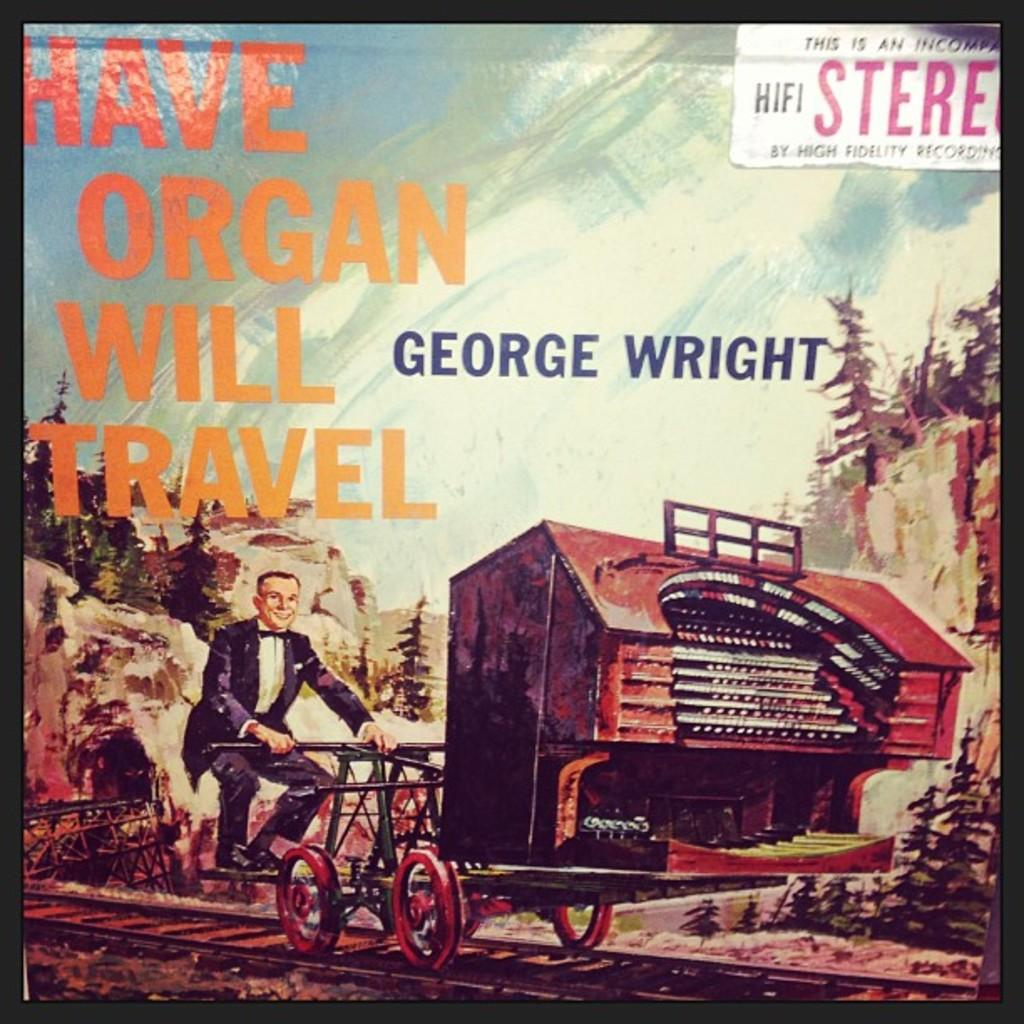What type of image is being described? The image appears to be a cover page of a book. What is happening in the image? There is a man riding a vehicle on the railway track. What can be seen in the background of the image? There are hills surrounding the man and the railway track. What type of zephyr is depicted in the image? There is no zephyr present in the image; it features a man riding a vehicle on a railway track with hills in the background. 